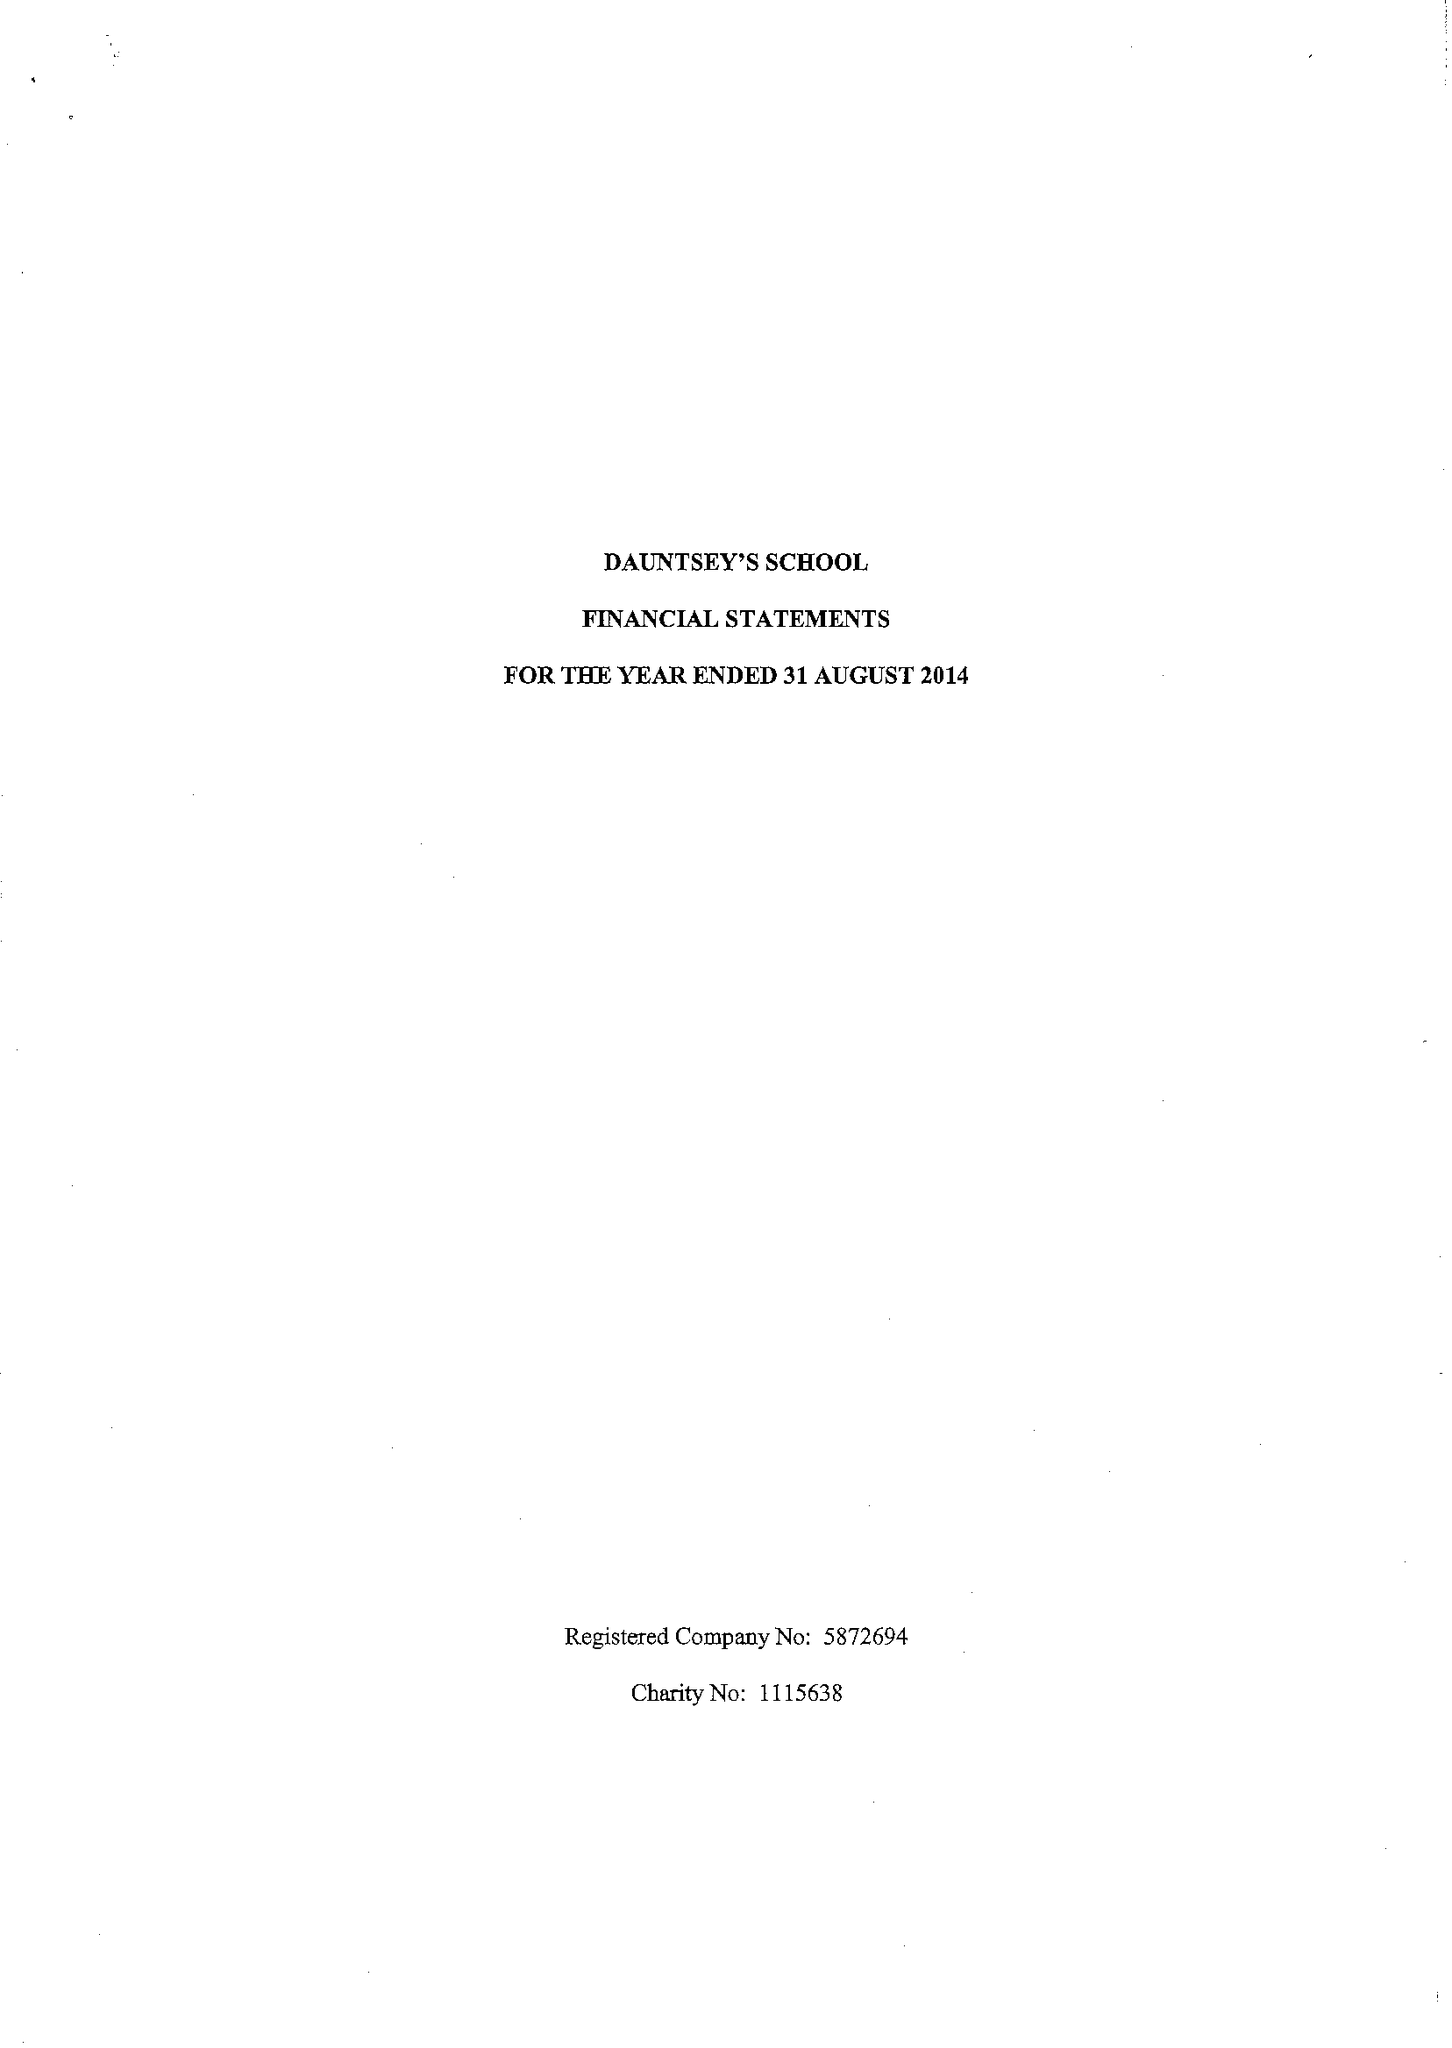What is the value for the charity_number?
Answer the question using a single word or phrase. 1115638 